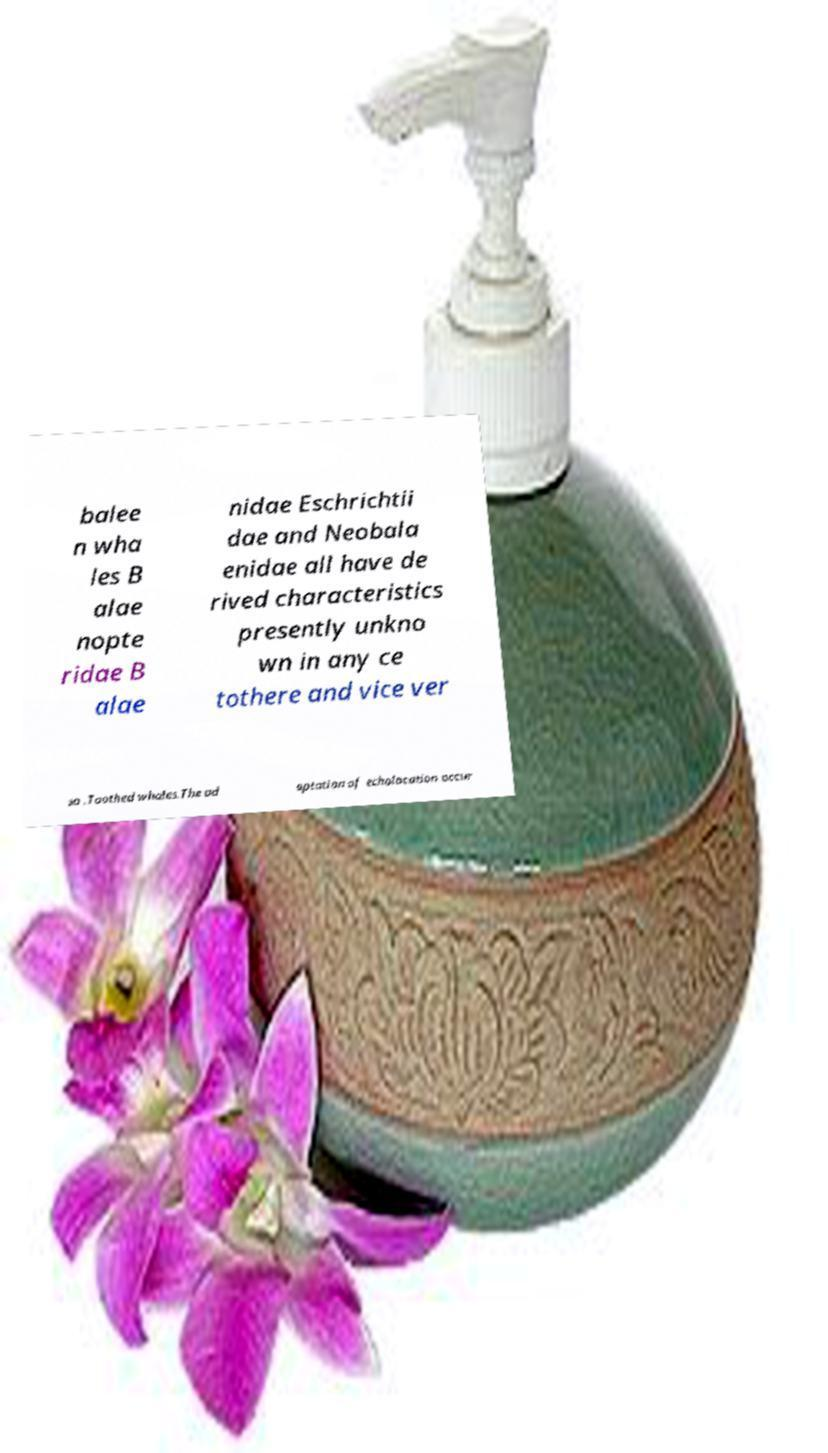Can you read and provide the text displayed in the image?This photo seems to have some interesting text. Can you extract and type it out for me? balee n wha les B alae nopte ridae B alae nidae Eschrichtii dae and Neobala enidae all have de rived characteristics presently unkno wn in any ce tothere and vice ver sa .Toothed whales.The ad aptation of echolocation occur 